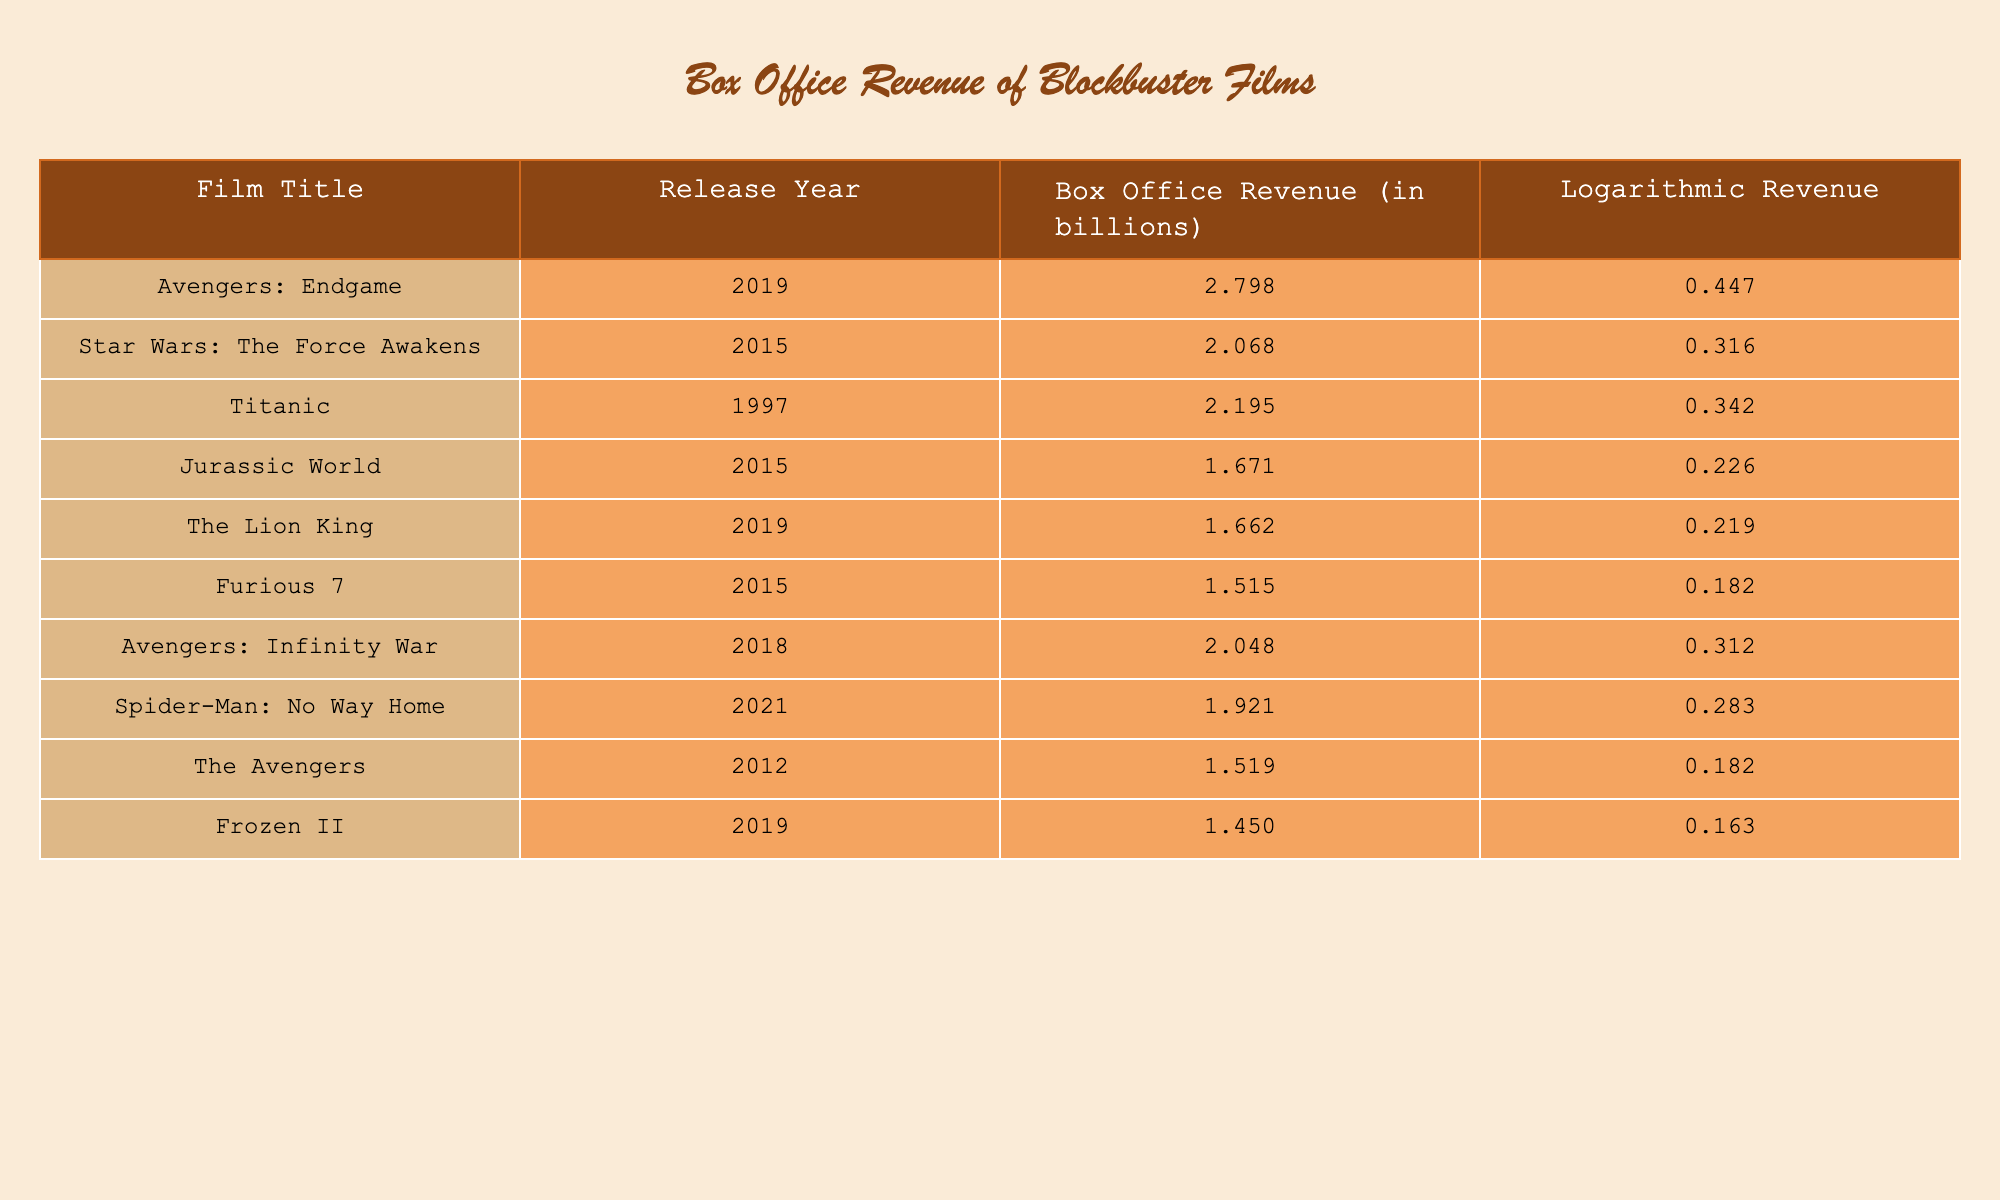What is the highest box office revenue among the films listed? The values in the "Box Office Revenue (in billions)" column indicate that "Avengers: Endgame" has the highest value of 2.798 billion.
Answer: 2.798 billion Which film has a logarithmic revenue of 0.447? The "Logarithmic Revenue" column shows that "Avengers: Endgame" has a logarithmic revenue of 0.447.
Answer: Avengers: Endgame What is the total box office revenue of all films released in 2015? The films released in 2015 are "Star Wars: The Force Awakens," "Jurassic World," and "Furious 7," with revenues of 2.068, 1.671, and 1.515 billion respectively. Adding these gives 2.068 + 1.671 + 1.515 = 5.254 billion.
Answer: 5.254 billion Is the box office revenue for "Titanic" greater than or equal to 2 billion? The revenue for "Titanic" is 2.195 billion, which is greater than 2 billion, making this statement true.
Answer: Yes What is the average box office revenue of the movies released in 2019? The films from 2019 are "Avengers: Endgame," "The Lion King," and "Frozen II," with revenues of 2.798, 1.662, and 1.450 billion respectively. The total sum is 2.798 + 1.662 + 1.450 = 5.910 billion. Dividing by the number of films, 5.910 / 3 = 1.970 billion.
Answer: 1.970 billion 